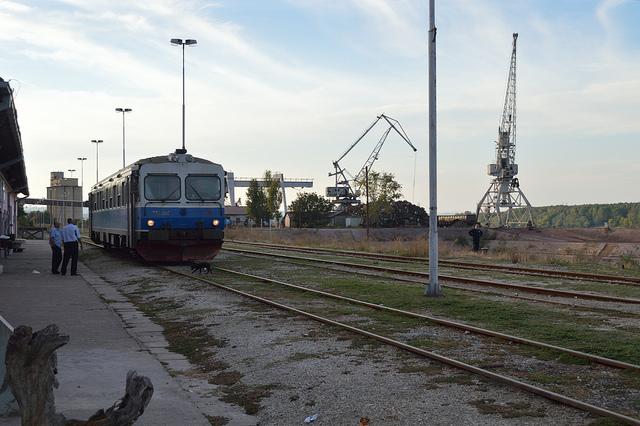What letters are on the tower?
Short answer required. 0. Are there flowers growing beside the railroad?
Write a very short answer. No. Are there any people?
Be succinct. Yes. Are the people in the photo dressed in identical uniforms?
Concise answer only. Yes. How many sets of tracks?
Write a very short answer. 3. What is on the ground?
Concise answer only. Train tracks. What season does it appear to be?
Be succinct. Summer. What is growing between the tracks?
Keep it brief. Grass. What color is the front of this train?
Be succinct. Blue and white. Might one assume an airport is nearby?
Short answer required. No. How many sets of tracks are there?
Be succinct. 3. How many people are in this photo?
Quick response, please. 2. Is the train stopped?
Answer briefly. Yes. Is the train driving at high speed?
Answer briefly. No. Is there anyone on the train track?
Write a very short answer. No. Are the planting their garden?
Give a very brief answer. No. What color is the train?
Concise answer only. Blue. Is that a long train?
Answer briefly. No. 